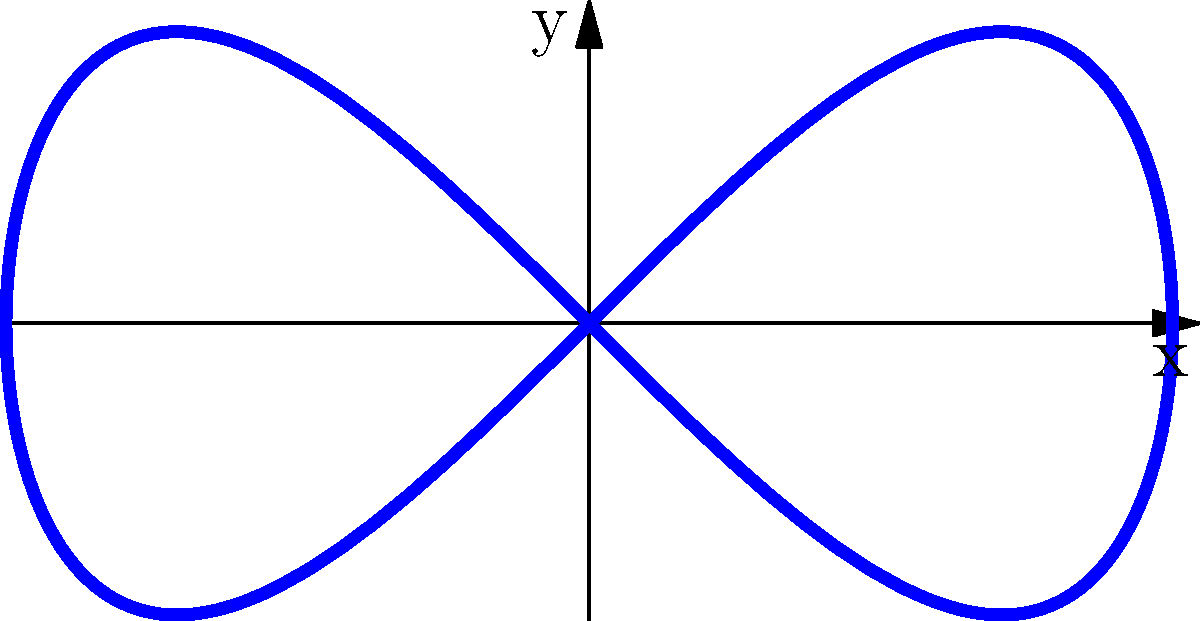As a digital illustrator, you want to create a smooth brush stroke using parametric equations. The curve shown is described by the parametric equations $x = 2\cos(t)$ and $y = \sin(2t)$ for $0 \leq t \leq 2\pi$. What is the maximum y-coordinate reached by this curve? To find the maximum y-coordinate, we need to analyze the function $y = \sin(2t)$:

1) The sine function has a range of [-1, 1], meaning its maximum value is 1.

2) The coefficient 2 inside $\sin(2t)$ doesn't affect the maximum value, it only changes the frequency of the oscillation.

3) There's no vertical scaling factor outside the sine function, so the maximum y-value remains 1.

4) To verify, we can find the critical points by setting the derivative of y with respect to t to zero:

   $\frac{dy}{dt} = 2\cos(2t) = 0$

   This occurs when $2t = \frac{\pi}{2}$ or $\frac{3\pi}{2}$, i.e., when $t = \frac{\pi}{4}$ or $\frac{3\pi}{4}$.

5) Evaluating $y$ at these points:

   $y(\frac{\pi}{4}) = \sin(2 \cdot \frac{\pi}{4}) = \sin(\frac{\pi}{2}) = 1$
   $y(\frac{3\pi}{4}) = \sin(2 \cdot \frac{3\pi}{4}) = \sin(\frac{3\pi}{2}) = -1$

6) This confirms that the maximum y-coordinate is 1.
Answer: 1 